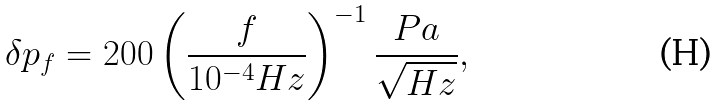<formula> <loc_0><loc_0><loc_500><loc_500>\delta p _ { f } = 2 0 0 \left ( \frac { f } { 1 0 ^ { - 4 } H z } \right ) ^ { - 1 } \frac { P a } { \sqrt { H z } } ,</formula> 